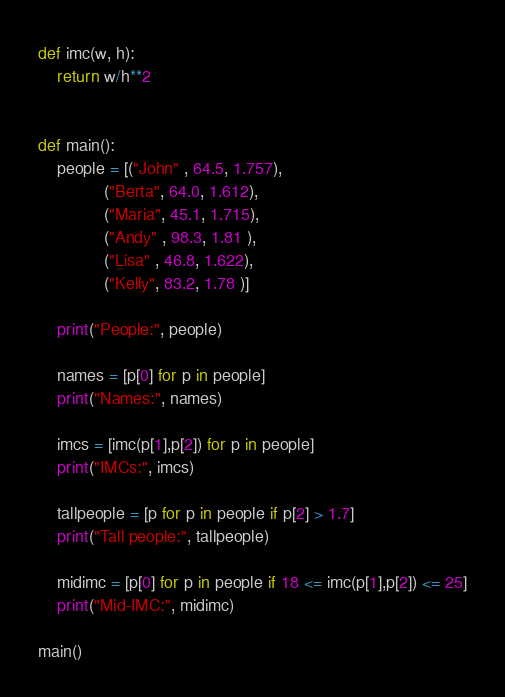Convert code to text. <code><loc_0><loc_0><loc_500><loc_500><_Python_>def imc(w, h):
    return w/h**2


def main():
    people = [("John" , 64.5, 1.757),
              ("Berta", 64.0, 1.612),
              ("Maria", 45.1, 1.715),
              ("Andy" , 98.3, 1.81 ),
              ("Lisa" , 46.8, 1.622),
              ("Kelly", 83.2, 1.78 )]

    print("People:", people)

    names = [p[0] for p in people]
    print("Names:", names)
    
    imcs = [imc(p[1],p[2]) for p in people]
    print("IMCs:", imcs)

    tallpeople = [p for p in people if p[2] > 1.7]
    print("Tall people:", tallpeople)    
    
    midimc = [p[0] for p in people if 18 <= imc(p[1],p[2]) <= 25]
    print("Mid-IMC:", midimc)

main()</code> 